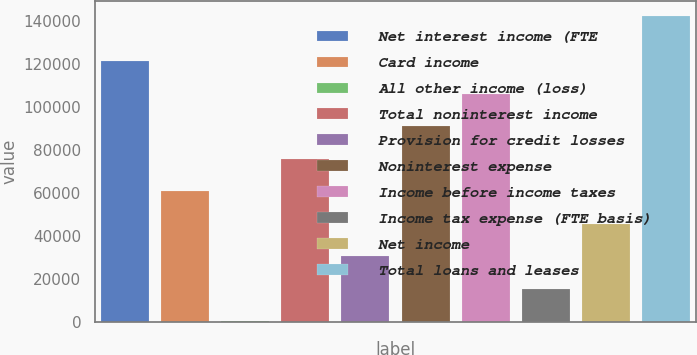<chart> <loc_0><loc_0><loc_500><loc_500><bar_chart><fcel>Net interest income (FTE<fcel>Card income<fcel>All other income (loss)<fcel>Total noninterest income<fcel>Provision for credit losses<fcel>Noninterest expense<fcel>Income before income taxes<fcel>Income tax expense (FTE basis)<fcel>Net income<fcel>Total loans and leases<nl><fcel>121213<fcel>60754.2<fcel>295<fcel>75869<fcel>30524.6<fcel>90983.8<fcel>106099<fcel>15409.8<fcel>45639.4<fcel>142133<nl></chart> 